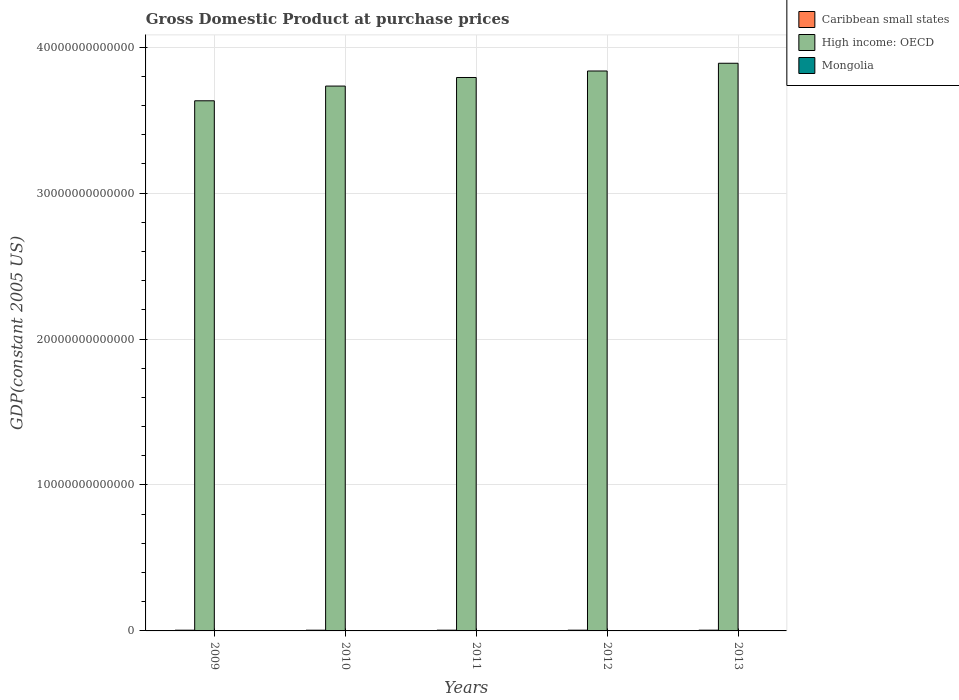How many groups of bars are there?
Provide a short and direct response. 5. Are the number of bars per tick equal to the number of legend labels?
Give a very brief answer. Yes. Are the number of bars on each tick of the X-axis equal?
Your response must be concise. Yes. In how many cases, is the number of bars for a given year not equal to the number of legend labels?
Offer a very short reply. 0. What is the GDP at purchase prices in Mongolia in 2011?
Your response must be concise. 4.05e+09. Across all years, what is the maximum GDP at purchase prices in High income: OECD?
Keep it short and to the point. 3.89e+13. Across all years, what is the minimum GDP at purchase prices in Caribbean small states?
Offer a terse response. 5.01e+1. In which year was the GDP at purchase prices in Mongolia maximum?
Offer a very short reply. 2013. In which year was the GDP at purchase prices in Caribbean small states minimum?
Make the answer very short. 2010. What is the total GDP at purchase prices in Caribbean small states in the graph?
Provide a succinct answer. 2.54e+11. What is the difference between the GDP at purchase prices in Caribbean small states in 2011 and that in 2013?
Make the answer very short. -1.16e+09. What is the difference between the GDP at purchase prices in Caribbean small states in 2009 and the GDP at purchase prices in Mongolia in 2012?
Offer a terse response. 4.56e+1. What is the average GDP at purchase prices in Mongolia per year?
Offer a very short reply. 4.08e+09. In the year 2009, what is the difference between the GDP at purchase prices in Mongolia and GDP at purchase prices in Caribbean small states?
Ensure brevity in your answer.  -4.69e+1. What is the ratio of the GDP at purchase prices in Caribbean small states in 2009 to that in 2012?
Keep it short and to the point. 0.98. Is the GDP at purchase prices in Caribbean small states in 2009 less than that in 2011?
Keep it short and to the point. Yes. What is the difference between the highest and the second highest GDP at purchase prices in Mongolia?
Provide a succinct answer. 5.30e+08. What is the difference between the highest and the lowest GDP at purchase prices in High income: OECD?
Offer a terse response. 2.57e+12. In how many years, is the GDP at purchase prices in High income: OECD greater than the average GDP at purchase prices in High income: OECD taken over all years?
Provide a succinct answer. 3. What does the 3rd bar from the left in 2011 represents?
Give a very brief answer. Mongolia. What does the 2nd bar from the right in 2009 represents?
Provide a succinct answer. High income: OECD. Are all the bars in the graph horizontal?
Ensure brevity in your answer.  No. What is the difference between two consecutive major ticks on the Y-axis?
Your answer should be compact. 1.00e+13. Are the values on the major ticks of Y-axis written in scientific E-notation?
Offer a very short reply. No. Does the graph contain any zero values?
Your response must be concise. No. Where does the legend appear in the graph?
Give a very brief answer. Top right. How many legend labels are there?
Your answer should be very brief. 3. How are the legend labels stacked?
Give a very brief answer. Vertical. What is the title of the graph?
Keep it short and to the point. Gross Domestic Product at purchase prices. What is the label or title of the Y-axis?
Your answer should be compact. GDP(constant 2005 US). What is the GDP(constant 2005 US) of Caribbean small states in 2009?
Provide a succinct answer. 5.01e+1. What is the GDP(constant 2005 US) of High income: OECD in 2009?
Make the answer very short. 3.63e+13. What is the GDP(constant 2005 US) in Mongolia in 2009?
Offer a terse response. 3.25e+09. What is the GDP(constant 2005 US) of Caribbean small states in 2010?
Keep it short and to the point. 5.01e+1. What is the GDP(constant 2005 US) in High income: OECD in 2010?
Your response must be concise. 3.73e+13. What is the GDP(constant 2005 US) of Mongolia in 2010?
Ensure brevity in your answer.  3.45e+09. What is the GDP(constant 2005 US) of Caribbean small states in 2011?
Provide a short and direct response. 5.06e+1. What is the GDP(constant 2005 US) of High income: OECD in 2011?
Provide a succinct answer. 3.79e+13. What is the GDP(constant 2005 US) in Mongolia in 2011?
Your response must be concise. 4.05e+09. What is the GDP(constant 2005 US) in Caribbean small states in 2012?
Your response must be concise. 5.11e+1. What is the GDP(constant 2005 US) of High income: OECD in 2012?
Offer a very short reply. 3.84e+13. What is the GDP(constant 2005 US) in Mongolia in 2012?
Ensure brevity in your answer.  4.55e+09. What is the GDP(constant 2005 US) of Caribbean small states in 2013?
Provide a short and direct response. 5.17e+1. What is the GDP(constant 2005 US) in High income: OECD in 2013?
Offer a terse response. 3.89e+13. What is the GDP(constant 2005 US) in Mongolia in 2013?
Your answer should be very brief. 5.08e+09. Across all years, what is the maximum GDP(constant 2005 US) of Caribbean small states?
Provide a short and direct response. 5.17e+1. Across all years, what is the maximum GDP(constant 2005 US) of High income: OECD?
Provide a short and direct response. 3.89e+13. Across all years, what is the maximum GDP(constant 2005 US) in Mongolia?
Offer a terse response. 5.08e+09. Across all years, what is the minimum GDP(constant 2005 US) in Caribbean small states?
Keep it short and to the point. 5.01e+1. Across all years, what is the minimum GDP(constant 2005 US) of High income: OECD?
Offer a very short reply. 3.63e+13. Across all years, what is the minimum GDP(constant 2005 US) in Mongolia?
Your answer should be very brief. 3.25e+09. What is the total GDP(constant 2005 US) of Caribbean small states in the graph?
Ensure brevity in your answer.  2.54e+11. What is the total GDP(constant 2005 US) in High income: OECD in the graph?
Ensure brevity in your answer.  1.89e+14. What is the total GDP(constant 2005 US) in Mongolia in the graph?
Your response must be concise. 2.04e+1. What is the difference between the GDP(constant 2005 US) in Caribbean small states in 2009 and that in 2010?
Offer a terse response. 2.06e+05. What is the difference between the GDP(constant 2005 US) of High income: OECD in 2009 and that in 2010?
Your answer should be compact. -1.01e+12. What is the difference between the GDP(constant 2005 US) in Mongolia in 2009 and that in 2010?
Give a very brief answer. -2.07e+08. What is the difference between the GDP(constant 2005 US) in Caribbean small states in 2009 and that in 2011?
Ensure brevity in your answer.  -4.65e+08. What is the difference between the GDP(constant 2005 US) of High income: OECD in 2009 and that in 2011?
Make the answer very short. -1.60e+12. What is the difference between the GDP(constant 2005 US) in Mongolia in 2009 and that in 2011?
Keep it short and to the point. -8.04e+08. What is the difference between the GDP(constant 2005 US) in Caribbean small states in 2009 and that in 2012?
Provide a succinct answer. -1.02e+09. What is the difference between the GDP(constant 2005 US) in High income: OECD in 2009 and that in 2012?
Provide a short and direct response. -2.04e+12. What is the difference between the GDP(constant 2005 US) of Mongolia in 2009 and that in 2012?
Ensure brevity in your answer.  -1.30e+09. What is the difference between the GDP(constant 2005 US) of Caribbean small states in 2009 and that in 2013?
Ensure brevity in your answer.  -1.62e+09. What is the difference between the GDP(constant 2005 US) of High income: OECD in 2009 and that in 2013?
Offer a very short reply. -2.57e+12. What is the difference between the GDP(constant 2005 US) in Mongolia in 2009 and that in 2013?
Provide a succinct answer. -1.83e+09. What is the difference between the GDP(constant 2005 US) of Caribbean small states in 2010 and that in 2011?
Offer a terse response. -4.66e+08. What is the difference between the GDP(constant 2005 US) in High income: OECD in 2010 and that in 2011?
Provide a short and direct response. -5.88e+11. What is the difference between the GDP(constant 2005 US) in Mongolia in 2010 and that in 2011?
Your answer should be compact. -5.97e+08. What is the difference between the GDP(constant 2005 US) in Caribbean small states in 2010 and that in 2012?
Make the answer very short. -1.02e+09. What is the difference between the GDP(constant 2005 US) of High income: OECD in 2010 and that in 2012?
Offer a very short reply. -1.03e+12. What is the difference between the GDP(constant 2005 US) in Mongolia in 2010 and that in 2012?
Make the answer very short. -1.10e+09. What is the difference between the GDP(constant 2005 US) in Caribbean small states in 2010 and that in 2013?
Your response must be concise. -1.62e+09. What is the difference between the GDP(constant 2005 US) of High income: OECD in 2010 and that in 2013?
Your answer should be compact. -1.56e+12. What is the difference between the GDP(constant 2005 US) in Mongolia in 2010 and that in 2013?
Make the answer very short. -1.63e+09. What is the difference between the GDP(constant 2005 US) in Caribbean small states in 2011 and that in 2012?
Ensure brevity in your answer.  -5.59e+08. What is the difference between the GDP(constant 2005 US) of High income: OECD in 2011 and that in 2012?
Keep it short and to the point. -4.46e+11. What is the difference between the GDP(constant 2005 US) of Mongolia in 2011 and that in 2012?
Provide a succinct answer. -4.99e+08. What is the difference between the GDP(constant 2005 US) of Caribbean small states in 2011 and that in 2013?
Your answer should be compact. -1.16e+09. What is the difference between the GDP(constant 2005 US) of High income: OECD in 2011 and that in 2013?
Ensure brevity in your answer.  -9.75e+11. What is the difference between the GDP(constant 2005 US) of Mongolia in 2011 and that in 2013?
Make the answer very short. -1.03e+09. What is the difference between the GDP(constant 2005 US) of Caribbean small states in 2012 and that in 2013?
Keep it short and to the point. -5.98e+08. What is the difference between the GDP(constant 2005 US) of High income: OECD in 2012 and that in 2013?
Offer a terse response. -5.30e+11. What is the difference between the GDP(constant 2005 US) of Mongolia in 2012 and that in 2013?
Your answer should be compact. -5.30e+08. What is the difference between the GDP(constant 2005 US) in Caribbean small states in 2009 and the GDP(constant 2005 US) in High income: OECD in 2010?
Provide a short and direct response. -3.73e+13. What is the difference between the GDP(constant 2005 US) in Caribbean small states in 2009 and the GDP(constant 2005 US) in Mongolia in 2010?
Offer a terse response. 4.67e+1. What is the difference between the GDP(constant 2005 US) of High income: OECD in 2009 and the GDP(constant 2005 US) of Mongolia in 2010?
Your answer should be very brief. 3.63e+13. What is the difference between the GDP(constant 2005 US) in Caribbean small states in 2009 and the GDP(constant 2005 US) in High income: OECD in 2011?
Ensure brevity in your answer.  -3.79e+13. What is the difference between the GDP(constant 2005 US) of Caribbean small states in 2009 and the GDP(constant 2005 US) of Mongolia in 2011?
Provide a short and direct response. 4.61e+1. What is the difference between the GDP(constant 2005 US) of High income: OECD in 2009 and the GDP(constant 2005 US) of Mongolia in 2011?
Your answer should be very brief. 3.63e+13. What is the difference between the GDP(constant 2005 US) of Caribbean small states in 2009 and the GDP(constant 2005 US) of High income: OECD in 2012?
Provide a short and direct response. -3.83e+13. What is the difference between the GDP(constant 2005 US) of Caribbean small states in 2009 and the GDP(constant 2005 US) of Mongolia in 2012?
Your answer should be very brief. 4.56e+1. What is the difference between the GDP(constant 2005 US) in High income: OECD in 2009 and the GDP(constant 2005 US) in Mongolia in 2012?
Your response must be concise. 3.63e+13. What is the difference between the GDP(constant 2005 US) in Caribbean small states in 2009 and the GDP(constant 2005 US) in High income: OECD in 2013?
Ensure brevity in your answer.  -3.88e+13. What is the difference between the GDP(constant 2005 US) in Caribbean small states in 2009 and the GDP(constant 2005 US) in Mongolia in 2013?
Offer a very short reply. 4.50e+1. What is the difference between the GDP(constant 2005 US) of High income: OECD in 2009 and the GDP(constant 2005 US) of Mongolia in 2013?
Offer a terse response. 3.63e+13. What is the difference between the GDP(constant 2005 US) of Caribbean small states in 2010 and the GDP(constant 2005 US) of High income: OECD in 2011?
Offer a terse response. -3.79e+13. What is the difference between the GDP(constant 2005 US) of Caribbean small states in 2010 and the GDP(constant 2005 US) of Mongolia in 2011?
Offer a terse response. 4.61e+1. What is the difference between the GDP(constant 2005 US) of High income: OECD in 2010 and the GDP(constant 2005 US) of Mongolia in 2011?
Provide a succinct answer. 3.73e+13. What is the difference between the GDP(constant 2005 US) of Caribbean small states in 2010 and the GDP(constant 2005 US) of High income: OECD in 2012?
Make the answer very short. -3.83e+13. What is the difference between the GDP(constant 2005 US) of Caribbean small states in 2010 and the GDP(constant 2005 US) of Mongolia in 2012?
Your response must be concise. 4.56e+1. What is the difference between the GDP(constant 2005 US) in High income: OECD in 2010 and the GDP(constant 2005 US) in Mongolia in 2012?
Keep it short and to the point. 3.73e+13. What is the difference between the GDP(constant 2005 US) in Caribbean small states in 2010 and the GDP(constant 2005 US) in High income: OECD in 2013?
Give a very brief answer. -3.88e+13. What is the difference between the GDP(constant 2005 US) of Caribbean small states in 2010 and the GDP(constant 2005 US) of Mongolia in 2013?
Your response must be concise. 4.50e+1. What is the difference between the GDP(constant 2005 US) in High income: OECD in 2010 and the GDP(constant 2005 US) in Mongolia in 2013?
Make the answer very short. 3.73e+13. What is the difference between the GDP(constant 2005 US) in Caribbean small states in 2011 and the GDP(constant 2005 US) in High income: OECD in 2012?
Keep it short and to the point. -3.83e+13. What is the difference between the GDP(constant 2005 US) in Caribbean small states in 2011 and the GDP(constant 2005 US) in Mongolia in 2012?
Offer a terse response. 4.60e+1. What is the difference between the GDP(constant 2005 US) of High income: OECD in 2011 and the GDP(constant 2005 US) of Mongolia in 2012?
Your answer should be compact. 3.79e+13. What is the difference between the GDP(constant 2005 US) of Caribbean small states in 2011 and the GDP(constant 2005 US) of High income: OECD in 2013?
Provide a succinct answer. -3.88e+13. What is the difference between the GDP(constant 2005 US) in Caribbean small states in 2011 and the GDP(constant 2005 US) in Mongolia in 2013?
Provide a succinct answer. 4.55e+1. What is the difference between the GDP(constant 2005 US) of High income: OECD in 2011 and the GDP(constant 2005 US) of Mongolia in 2013?
Your response must be concise. 3.79e+13. What is the difference between the GDP(constant 2005 US) of Caribbean small states in 2012 and the GDP(constant 2005 US) of High income: OECD in 2013?
Make the answer very short. -3.88e+13. What is the difference between the GDP(constant 2005 US) of Caribbean small states in 2012 and the GDP(constant 2005 US) of Mongolia in 2013?
Offer a very short reply. 4.61e+1. What is the difference between the GDP(constant 2005 US) of High income: OECD in 2012 and the GDP(constant 2005 US) of Mongolia in 2013?
Your response must be concise. 3.84e+13. What is the average GDP(constant 2005 US) of Caribbean small states per year?
Give a very brief answer. 5.07e+1. What is the average GDP(constant 2005 US) of High income: OECD per year?
Your answer should be compact. 3.78e+13. What is the average GDP(constant 2005 US) of Mongolia per year?
Your response must be concise. 4.08e+09. In the year 2009, what is the difference between the GDP(constant 2005 US) of Caribbean small states and GDP(constant 2005 US) of High income: OECD?
Your answer should be compact. -3.63e+13. In the year 2009, what is the difference between the GDP(constant 2005 US) of Caribbean small states and GDP(constant 2005 US) of Mongolia?
Your answer should be compact. 4.69e+1. In the year 2009, what is the difference between the GDP(constant 2005 US) in High income: OECD and GDP(constant 2005 US) in Mongolia?
Offer a very short reply. 3.63e+13. In the year 2010, what is the difference between the GDP(constant 2005 US) of Caribbean small states and GDP(constant 2005 US) of High income: OECD?
Your answer should be very brief. -3.73e+13. In the year 2010, what is the difference between the GDP(constant 2005 US) in Caribbean small states and GDP(constant 2005 US) in Mongolia?
Your answer should be very brief. 4.67e+1. In the year 2010, what is the difference between the GDP(constant 2005 US) in High income: OECD and GDP(constant 2005 US) in Mongolia?
Offer a very short reply. 3.73e+13. In the year 2011, what is the difference between the GDP(constant 2005 US) of Caribbean small states and GDP(constant 2005 US) of High income: OECD?
Provide a short and direct response. -3.79e+13. In the year 2011, what is the difference between the GDP(constant 2005 US) of Caribbean small states and GDP(constant 2005 US) of Mongolia?
Offer a very short reply. 4.65e+1. In the year 2011, what is the difference between the GDP(constant 2005 US) of High income: OECD and GDP(constant 2005 US) of Mongolia?
Give a very brief answer. 3.79e+13. In the year 2012, what is the difference between the GDP(constant 2005 US) in Caribbean small states and GDP(constant 2005 US) in High income: OECD?
Offer a very short reply. -3.83e+13. In the year 2012, what is the difference between the GDP(constant 2005 US) in Caribbean small states and GDP(constant 2005 US) in Mongolia?
Provide a succinct answer. 4.66e+1. In the year 2012, what is the difference between the GDP(constant 2005 US) in High income: OECD and GDP(constant 2005 US) in Mongolia?
Your answer should be very brief. 3.84e+13. In the year 2013, what is the difference between the GDP(constant 2005 US) in Caribbean small states and GDP(constant 2005 US) in High income: OECD?
Ensure brevity in your answer.  -3.88e+13. In the year 2013, what is the difference between the GDP(constant 2005 US) of Caribbean small states and GDP(constant 2005 US) of Mongolia?
Your answer should be compact. 4.66e+1. In the year 2013, what is the difference between the GDP(constant 2005 US) in High income: OECD and GDP(constant 2005 US) in Mongolia?
Provide a succinct answer. 3.89e+13. What is the ratio of the GDP(constant 2005 US) in Caribbean small states in 2009 to that in 2010?
Ensure brevity in your answer.  1. What is the ratio of the GDP(constant 2005 US) in High income: OECD in 2009 to that in 2010?
Ensure brevity in your answer.  0.97. What is the ratio of the GDP(constant 2005 US) of Mongolia in 2009 to that in 2010?
Provide a short and direct response. 0.94. What is the ratio of the GDP(constant 2005 US) of High income: OECD in 2009 to that in 2011?
Keep it short and to the point. 0.96. What is the ratio of the GDP(constant 2005 US) of Mongolia in 2009 to that in 2011?
Provide a short and direct response. 0.8. What is the ratio of the GDP(constant 2005 US) of High income: OECD in 2009 to that in 2012?
Give a very brief answer. 0.95. What is the ratio of the GDP(constant 2005 US) of Mongolia in 2009 to that in 2012?
Provide a succinct answer. 0.71. What is the ratio of the GDP(constant 2005 US) in Caribbean small states in 2009 to that in 2013?
Ensure brevity in your answer.  0.97. What is the ratio of the GDP(constant 2005 US) in High income: OECD in 2009 to that in 2013?
Make the answer very short. 0.93. What is the ratio of the GDP(constant 2005 US) in Mongolia in 2009 to that in 2013?
Give a very brief answer. 0.64. What is the ratio of the GDP(constant 2005 US) in Caribbean small states in 2010 to that in 2011?
Offer a terse response. 0.99. What is the ratio of the GDP(constant 2005 US) in High income: OECD in 2010 to that in 2011?
Provide a short and direct response. 0.98. What is the ratio of the GDP(constant 2005 US) in Mongolia in 2010 to that in 2011?
Make the answer very short. 0.85. What is the ratio of the GDP(constant 2005 US) of High income: OECD in 2010 to that in 2012?
Make the answer very short. 0.97. What is the ratio of the GDP(constant 2005 US) of Mongolia in 2010 to that in 2012?
Provide a short and direct response. 0.76. What is the ratio of the GDP(constant 2005 US) in Caribbean small states in 2010 to that in 2013?
Provide a short and direct response. 0.97. What is the ratio of the GDP(constant 2005 US) in High income: OECD in 2010 to that in 2013?
Provide a short and direct response. 0.96. What is the ratio of the GDP(constant 2005 US) in Mongolia in 2010 to that in 2013?
Your answer should be very brief. 0.68. What is the ratio of the GDP(constant 2005 US) of High income: OECD in 2011 to that in 2012?
Provide a short and direct response. 0.99. What is the ratio of the GDP(constant 2005 US) in Mongolia in 2011 to that in 2012?
Your answer should be compact. 0.89. What is the ratio of the GDP(constant 2005 US) of Caribbean small states in 2011 to that in 2013?
Offer a very short reply. 0.98. What is the ratio of the GDP(constant 2005 US) of High income: OECD in 2011 to that in 2013?
Your answer should be very brief. 0.97. What is the ratio of the GDP(constant 2005 US) in Mongolia in 2011 to that in 2013?
Provide a succinct answer. 0.8. What is the ratio of the GDP(constant 2005 US) of Caribbean small states in 2012 to that in 2013?
Offer a very short reply. 0.99. What is the ratio of the GDP(constant 2005 US) in High income: OECD in 2012 to that in 2013?
Ensure brevity in your answer.  0.99. What is the ratio of the GDP(constant 2005 US) in Mongolia in 2012 to that in 2013?
Your answer should be compact. 0.9. What is the difference between the highest and the second highest GDP(constant 2005 US) in Caribbean small states?
Provide a succinct answer. 5.98e+08. What is the difference between the highest and the second highest GDP(constant 2005 US) of High income: OECD?
Ensure brevity in your answer.  5.30e+11. What is the difference between the highest and the second highest GDP(constant 2005 US) in Mongolia?
Ensure brevity in your answer.  5.30e+08. What is the difference between the highest and the lowest GDP(constant 2005 US) of Caribbean small states?
Offer a very short reply. 1.62e+09. What is the difference between the highest and the lowest GDP(constant 2005 US) in High income: OECD?
Your answer should be very brief. 2.57e+12. What is the difference between the highest and the lowest GDP(constant 2005 US) of Mongolia?
Provide a succinct answer. 1.83e+09. 